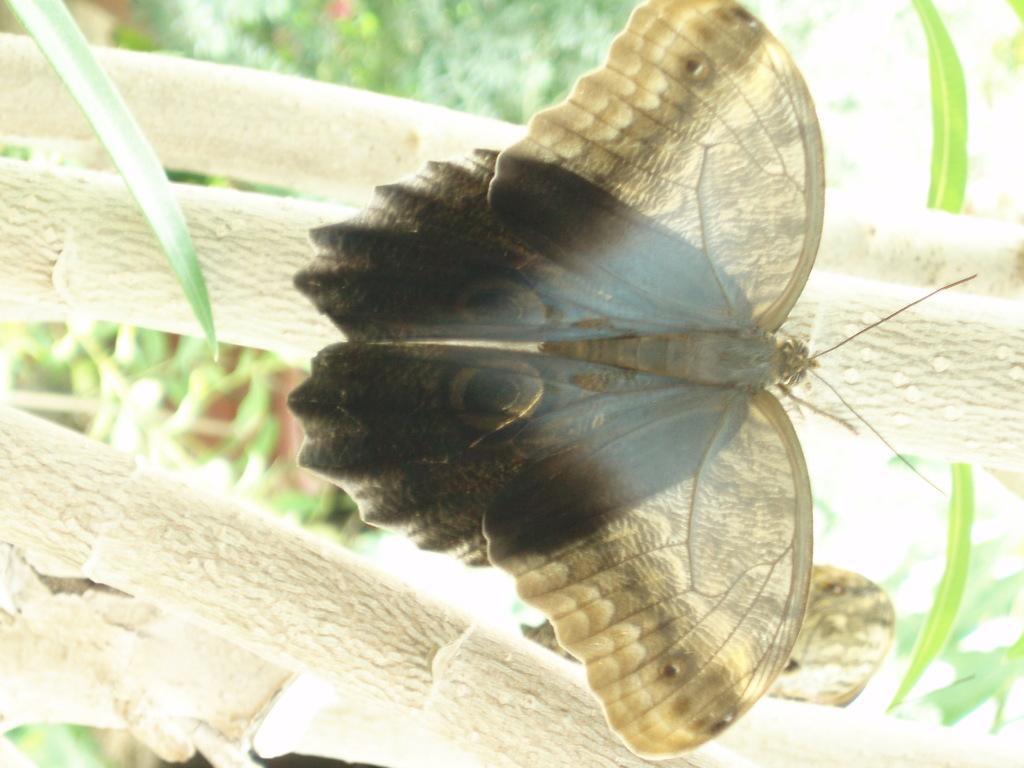In one or two sentences, can you explain what this image depicts? In this picture I can see a butterfly on the branch, there are leaves and there is blur background. 